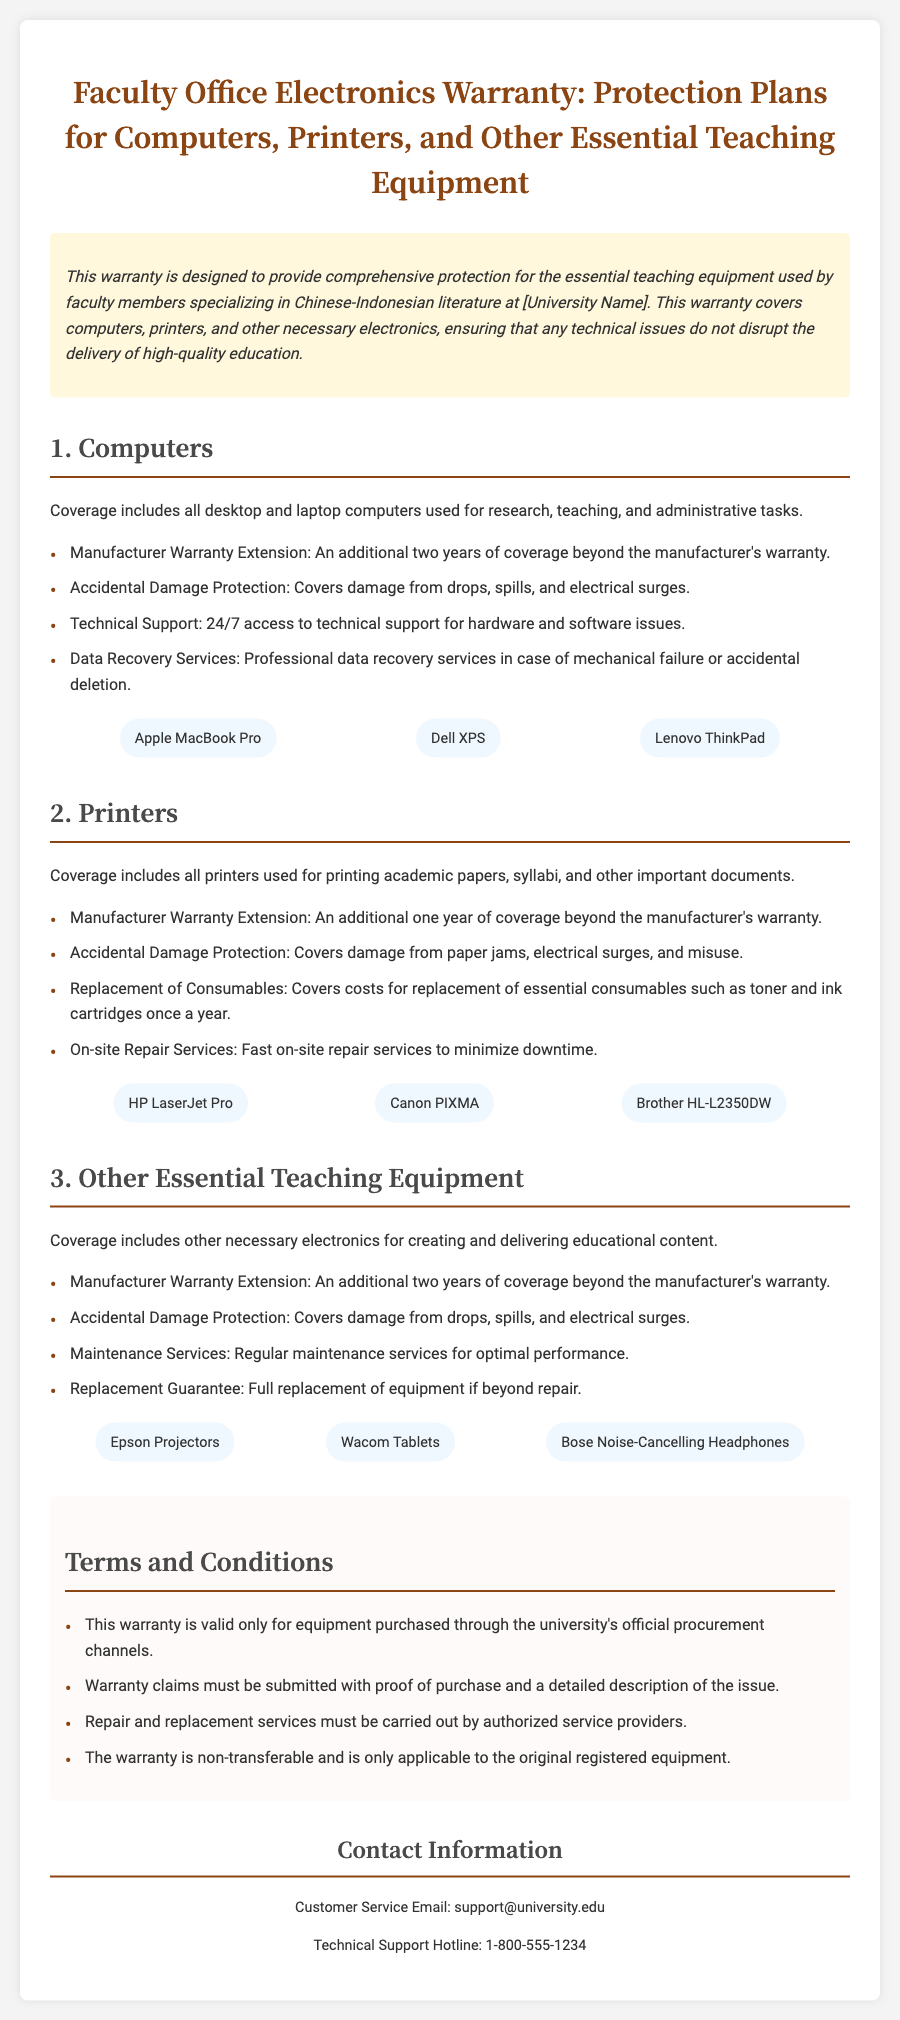What is the title of the document? The title can be found at the top of the document.
Answer: Faculty Office Electronics Warranty: Protection Plans for Computers, Printers, and Other Essential Teaching Equipment What does the warranty cover for computers? The document lists specific coverages under the "Computers" section.
Answer: Manufacturer Warranty Extension, Accidental Damage Protection, Technical Support, Data Recovery Services How long does the warranty extend for printers? The duration for printer coverage is specified in the "Printers" section.
Answer: One year What should be provided for warranty claims? The requirements for warranty claims are mentioned in the "Terms and Conditions" section.
Answer: Proof of purchase and a detailed description of the issue Which brands of laptops are included in the computer coverage? The brands are listed under the "Computers" section.
Answer: Apple MacBook Pro, Dell XPS, Lenovo ThinkPad What type of damage is covered under the Accidental Damage Protection for other teaching equipment? This information is found under the "Other Essential Teaching Equipment" coverage section.
Answer: Damage from drops, spills, and electrical surges Is the warranty transferable? This detail is addressed in the "Terms and Conditions" section.
Answer: No What is the contact email for customer service? The contact information is provided towards the end of the document.
Answer: support@university.edu 